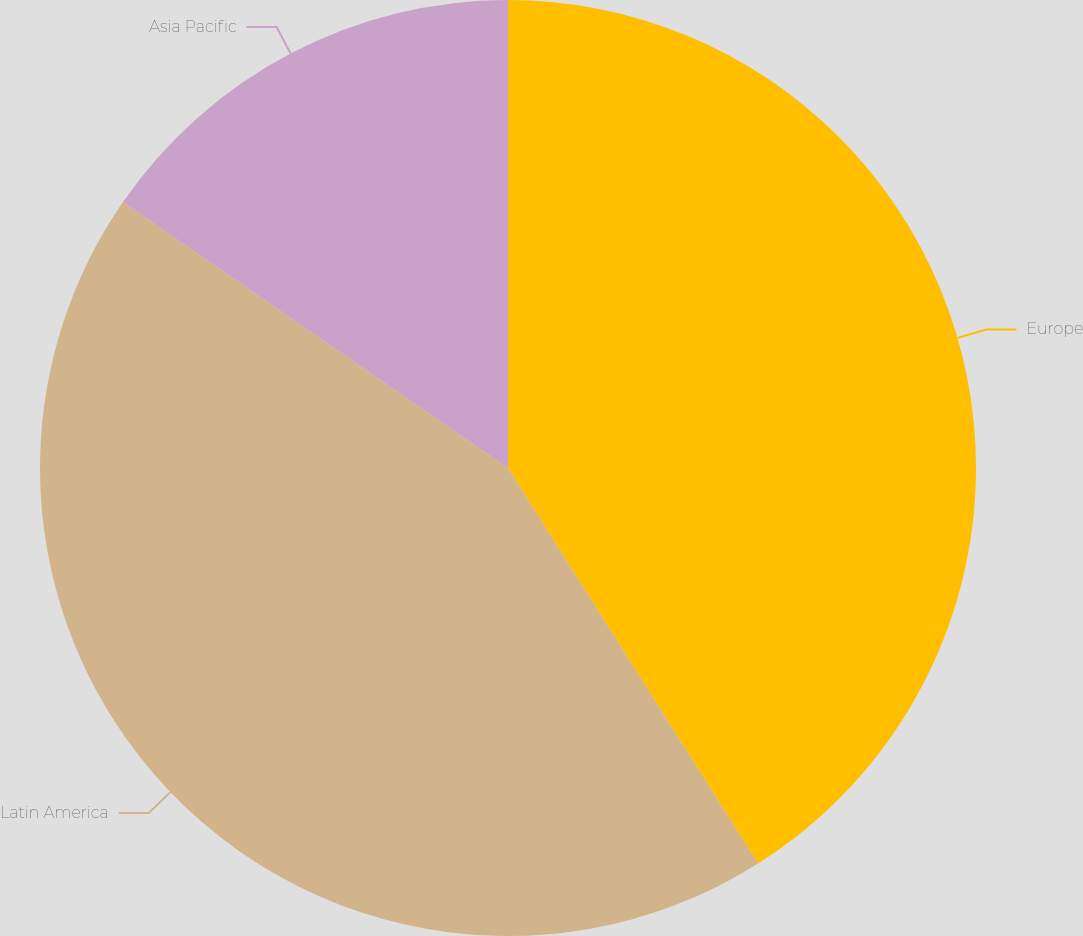<chart> <loc_0><loc_0><loc_500><loc_500><pie_chart><fcel>Europe<fcel>Latin America<fcel>Asia Pacific<nl><fcel>41.03%<fcel>43.59%<fcel>15.38%<nl></chart> 